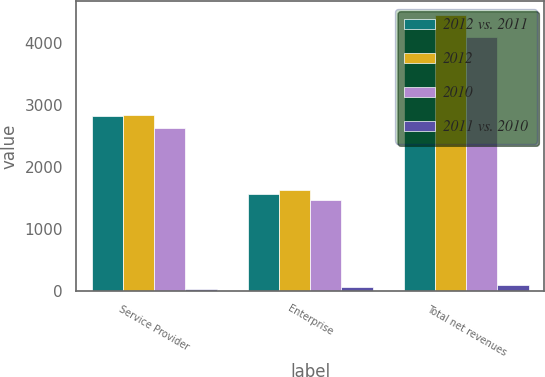Convert chart to OTSL. <chart><loc_0><loc_0><loc_500><loc_500><stacked_bar_chart><ecel><fcel>Service Provider<fcel>Enterprise<fcel>Total net revenues<nl><fcel>2012 vs. 2011<fcel>2811.2<fcel>1554.2<fcel>4365.4<nl><fcel>2012<fcel>2833<fcel>1615.7<fcel>4448.7<nl><fcel>2010<fcel>2631.5<fcel>1461.8<fcel>4093.3<nl><fcel>2011 vs. 2010<fcel>21.8<fcel>61.5<fcel>83.3<nl></chart> 